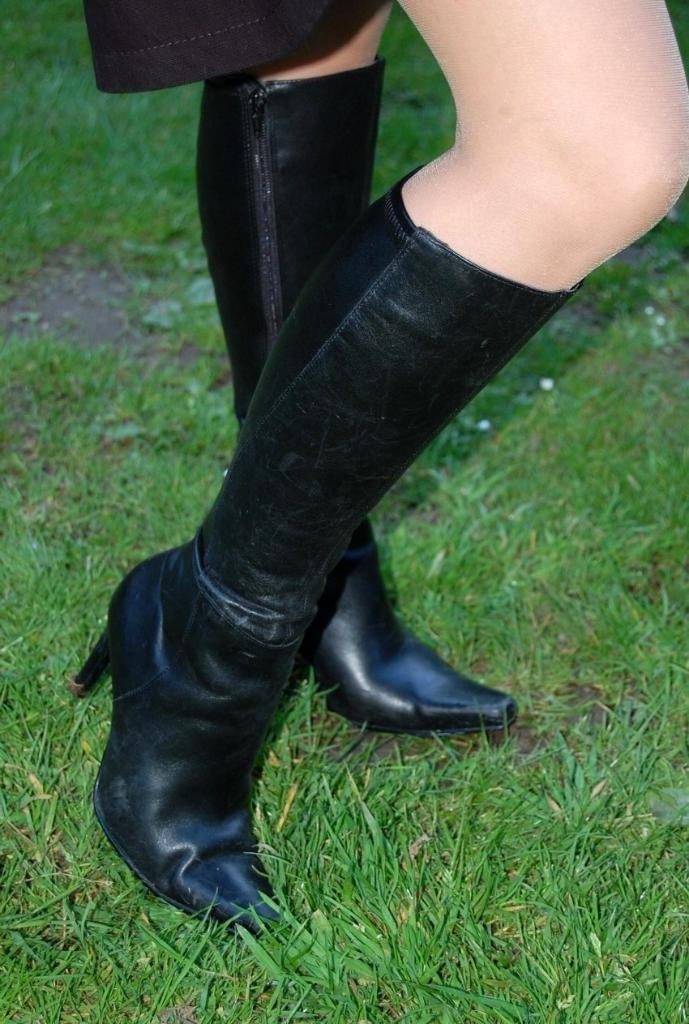What is present in the image? There is a person in the image. What type of footwear is the person wearing? The person is wearing black shoes. What is the surface the person is standing on? The person is standing on grassy land. What type of lamp is draped with a scarf in the image? There is no lamp or scarf present in the image; it features a person wearing black shoes and standing on grassy land. 